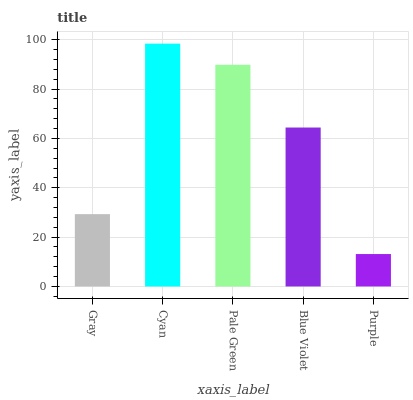Is Purple the minimum?
Answer yes or no. Yes. Is Cyan the maximum?
Answer yes or no. Yes. Is Pale Green the minimum?
Answer yes or no. No. Is Pale Green the maximum?
Answer yes or no. No. Is Cyan greater than Pale Green?
Answer yes or no. Yes. Is Pale Green less than Cyan?
Answer yes or no. Yes. Is Pale Green greater than Cyan?
Answer yes or no. No. Is Cyan less than Pale Green?
Answer yes or no. No. Is Blue Violet the high median?
Answer yes or no. Yes. Is Blue Violet the low median?
Answer yes or no. Yes. Is Gray the high median?
Answer yes or no. No. Is Purple the low median?
Answer yes or no. No. 